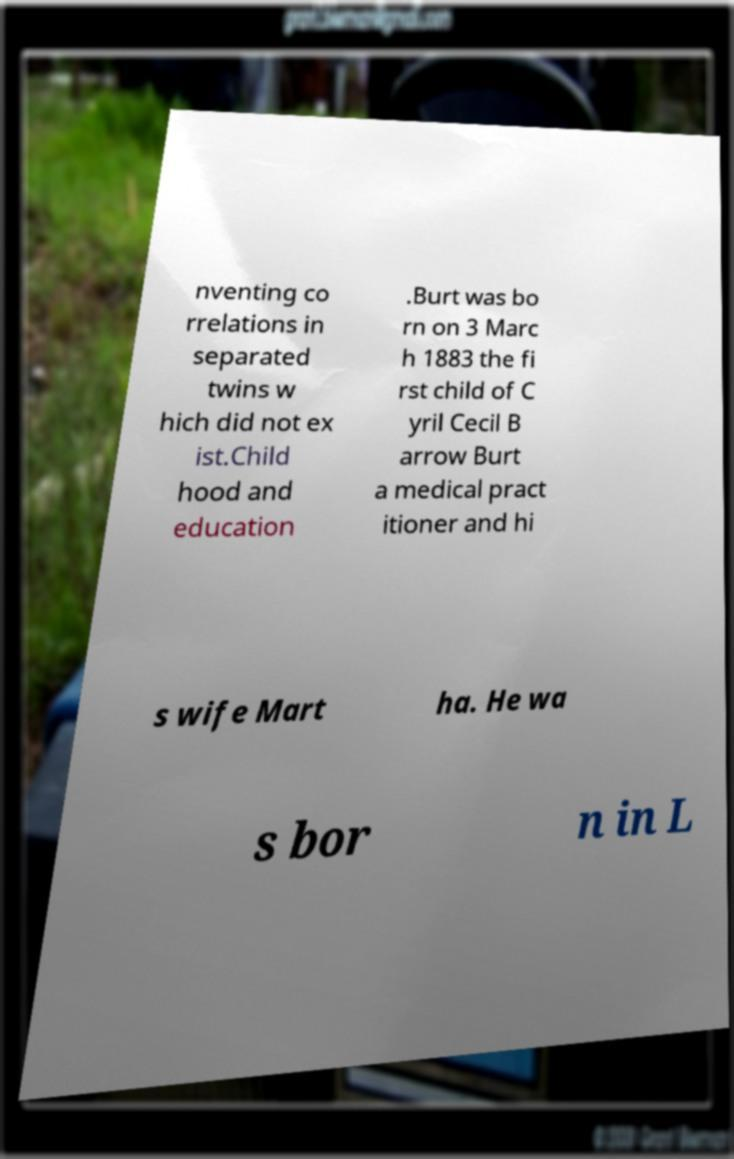I need the written content from this picture converted into text. Can you do that? nventing co rrelations in separated twins w hich did not ex ist.Child hood and education .Burt was bo rn on 3 Marc h 1883 the fi rst child of C yril Cecil B arrow Burt a medical pract itioner and hi s wife Mart ha. He wa s bor n in L 